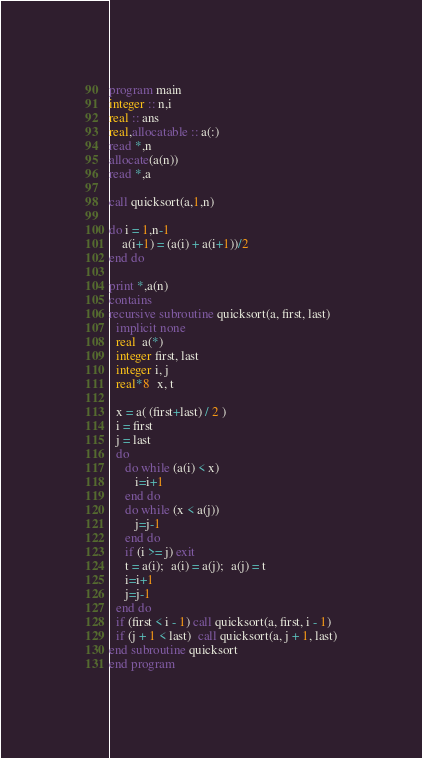<code> <loc_0><loc_0><loc_500><loc_500><_FORTRAN_>program main
integer :: n,i
real :: ans
real,allocatable :: a(:)
read *,n
allocate(a(n))
read *,a

call quicksort(a,1,n)

do i = 1,n-1
	a(i+1) = (a(i) + a(i+1))/2
end do

print *,a(n)
contains
recursive subroutine quicksort(a, first, last)
  implicit none
  real  a(*)
  integer first, last
  integer i, j
  real*8  x, t
  
  x = a( (first+last) / 2 )
  i = first
  j = last
  do
     do while (a(i) < x)
        i=i+1
     end do
     do while (x < a(j))
        j=j-1
     end do
     if (i >= j) exit
     t = a(i);  a(i) = a(j);  a(j) = t
     i=i+1
     j=j-1
  end do
  if (first < i - 1) call quicksort(a, first, i - 1)
  if (j + 1 < last)  call quicksort(a, j + 1, last)
end subroutine quicksort
end program</code> 